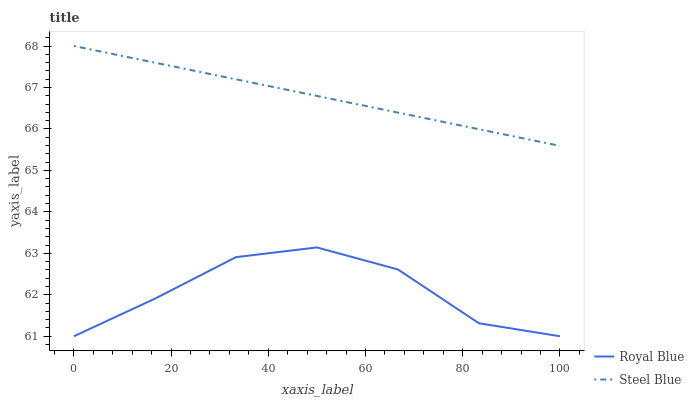Does Royal Blue have the minimum area under the curve?
Answer yes or no. Yes. Does Steel Blue have the maximum area under the curve?
Answer yes or no. Yes. Does Steel Blue have the minimum area under the curve?
Answer yes or no. No. Is Steel Blue the smoothest?
Answer yes or no. Yes. Is Royal Blue the roughest?
Answer yes or no. Yes. Is Steel Blue the roughest?
Answer yes or no. No. Does Royal Blue have the lowest value?
Answer yes or no. Yes. Does Steel Blue have the lowest value?
Answer yes or no. No. Does Steel Blue have the highest value?
Answer yes or no. Yes. Is Royal Blue less than Steel Blue?
Answer yes or no. Yes. Is Steel Blue greater than Royal Blue?
Answer yes or no. Yes. Does Royal Blue intersect Steel Blue?
Answer yes or no. No. 